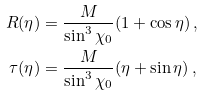Convert formula to latex. <formula><loc_0><loc_0><loc_500><loc_500>R ( \eta ) & = \frac { M } { \sin ^ { 3 } \chi _ { 0 } } ( 1 + \cos \eta ) \, , \\ \tau ( \eta ) & = \frac { M } { \sin ^ { 3 } \chi _ { 0 } } ( \eta + \sin \eta ) \, ,</formula> 